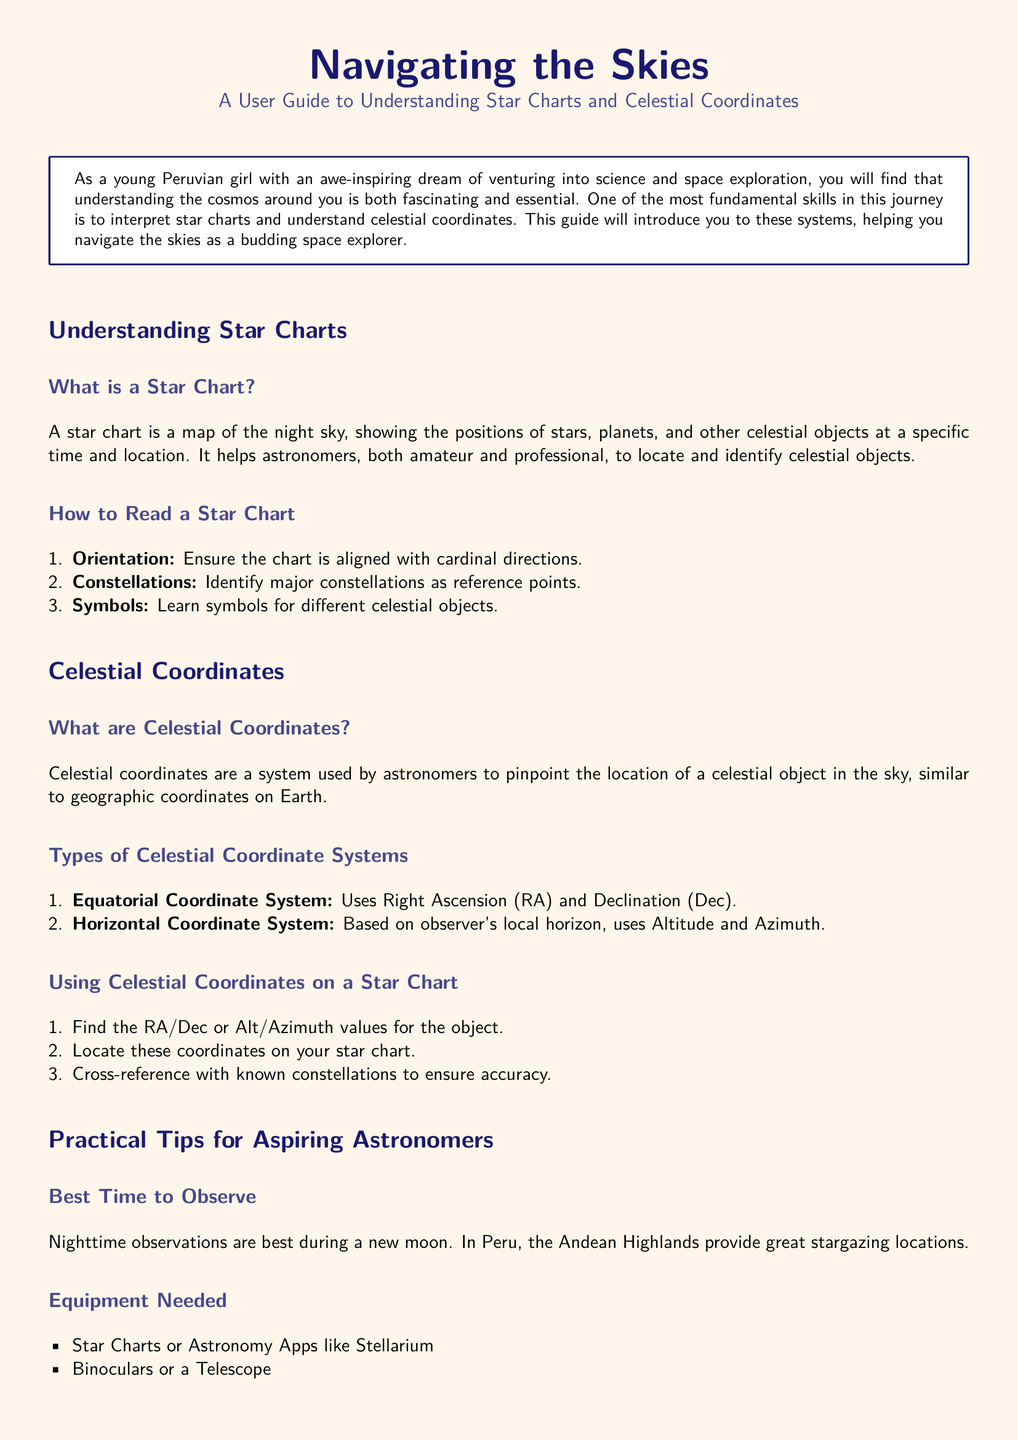What is a star chart? A star chart is a map of the night sky, showing the positions of stars, planets, and other celestial objects at a specific time and location.
Answer: A map of the night sky What two systems are mentioned for celestial coordinates? The document lists the Equatorial Coordinate System and the Horizontal Coordinate System as two types.
Answer: Equatorial and Horizontal What is the best time for nighttime observations? The guide suggests that nighttime observations are best during a new moon.
Answer: During a new moon What equipment is suggested for aspiring astronomers? The document recommends star charts or astronomy apps, binoculars or a telescope, and a red-light flashlight as essential equipment.
Answer: Star charts, binoculars, red-light flashlight How should one locate celestial coordinates on a star chart? To locate celestial coordinates, you should find the RA/Dec or Alt/Azimuth values for the object and locate these coordinates on your star chart.
Answer: Find RA/Dec or Alt/Azimuth values What major terrain is suggested for stargazing in Peru? The Andean Highlands are highlighted as great stargazing locations in Peru.
Answer: Andean Highlands 